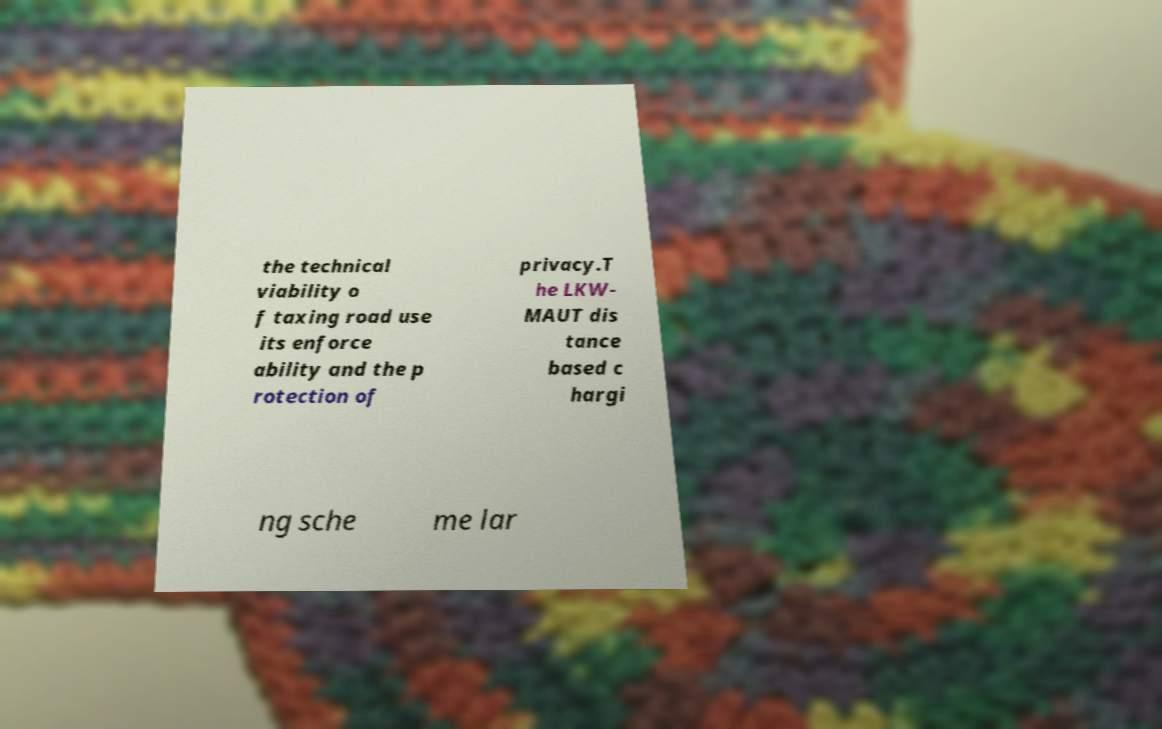Can you read and provide the text displayed in the image?This photo seems to have some interesting text. Can you extract and type it out for me? the technical viability o f taxing road use its enforce ability and the p rotection of privacy.T he LKW- MAUT dis tance based c hargi ng sche me lar 